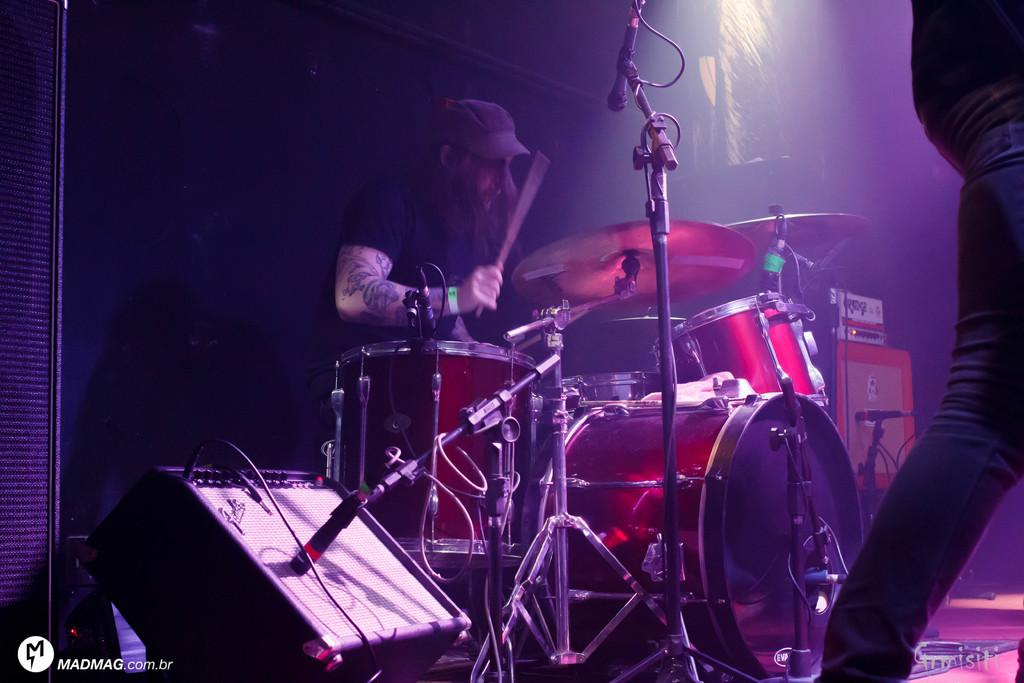How many people are in the image? There are two people in the image. What is the man doing in the image? The man is playing drums in the image. Where is the man positioned in relation to the microphone? The man is in front of a microphone. What can be seen in the background of the image? There are lights visible in the image. Can you tell me how many cherries are on the table in the image? There is no table or cherries present in the image. What type of bird can be seen flying in the image? There is no bird visible in the image. 